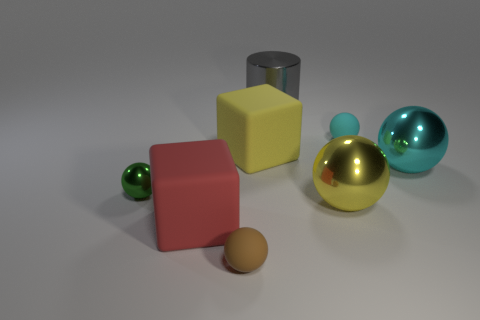Is there a large gray ball? There is no large gray ball visible in the image. The largest sphere present has a reflective golden surface, and there are other smaller spheres with different colors. 